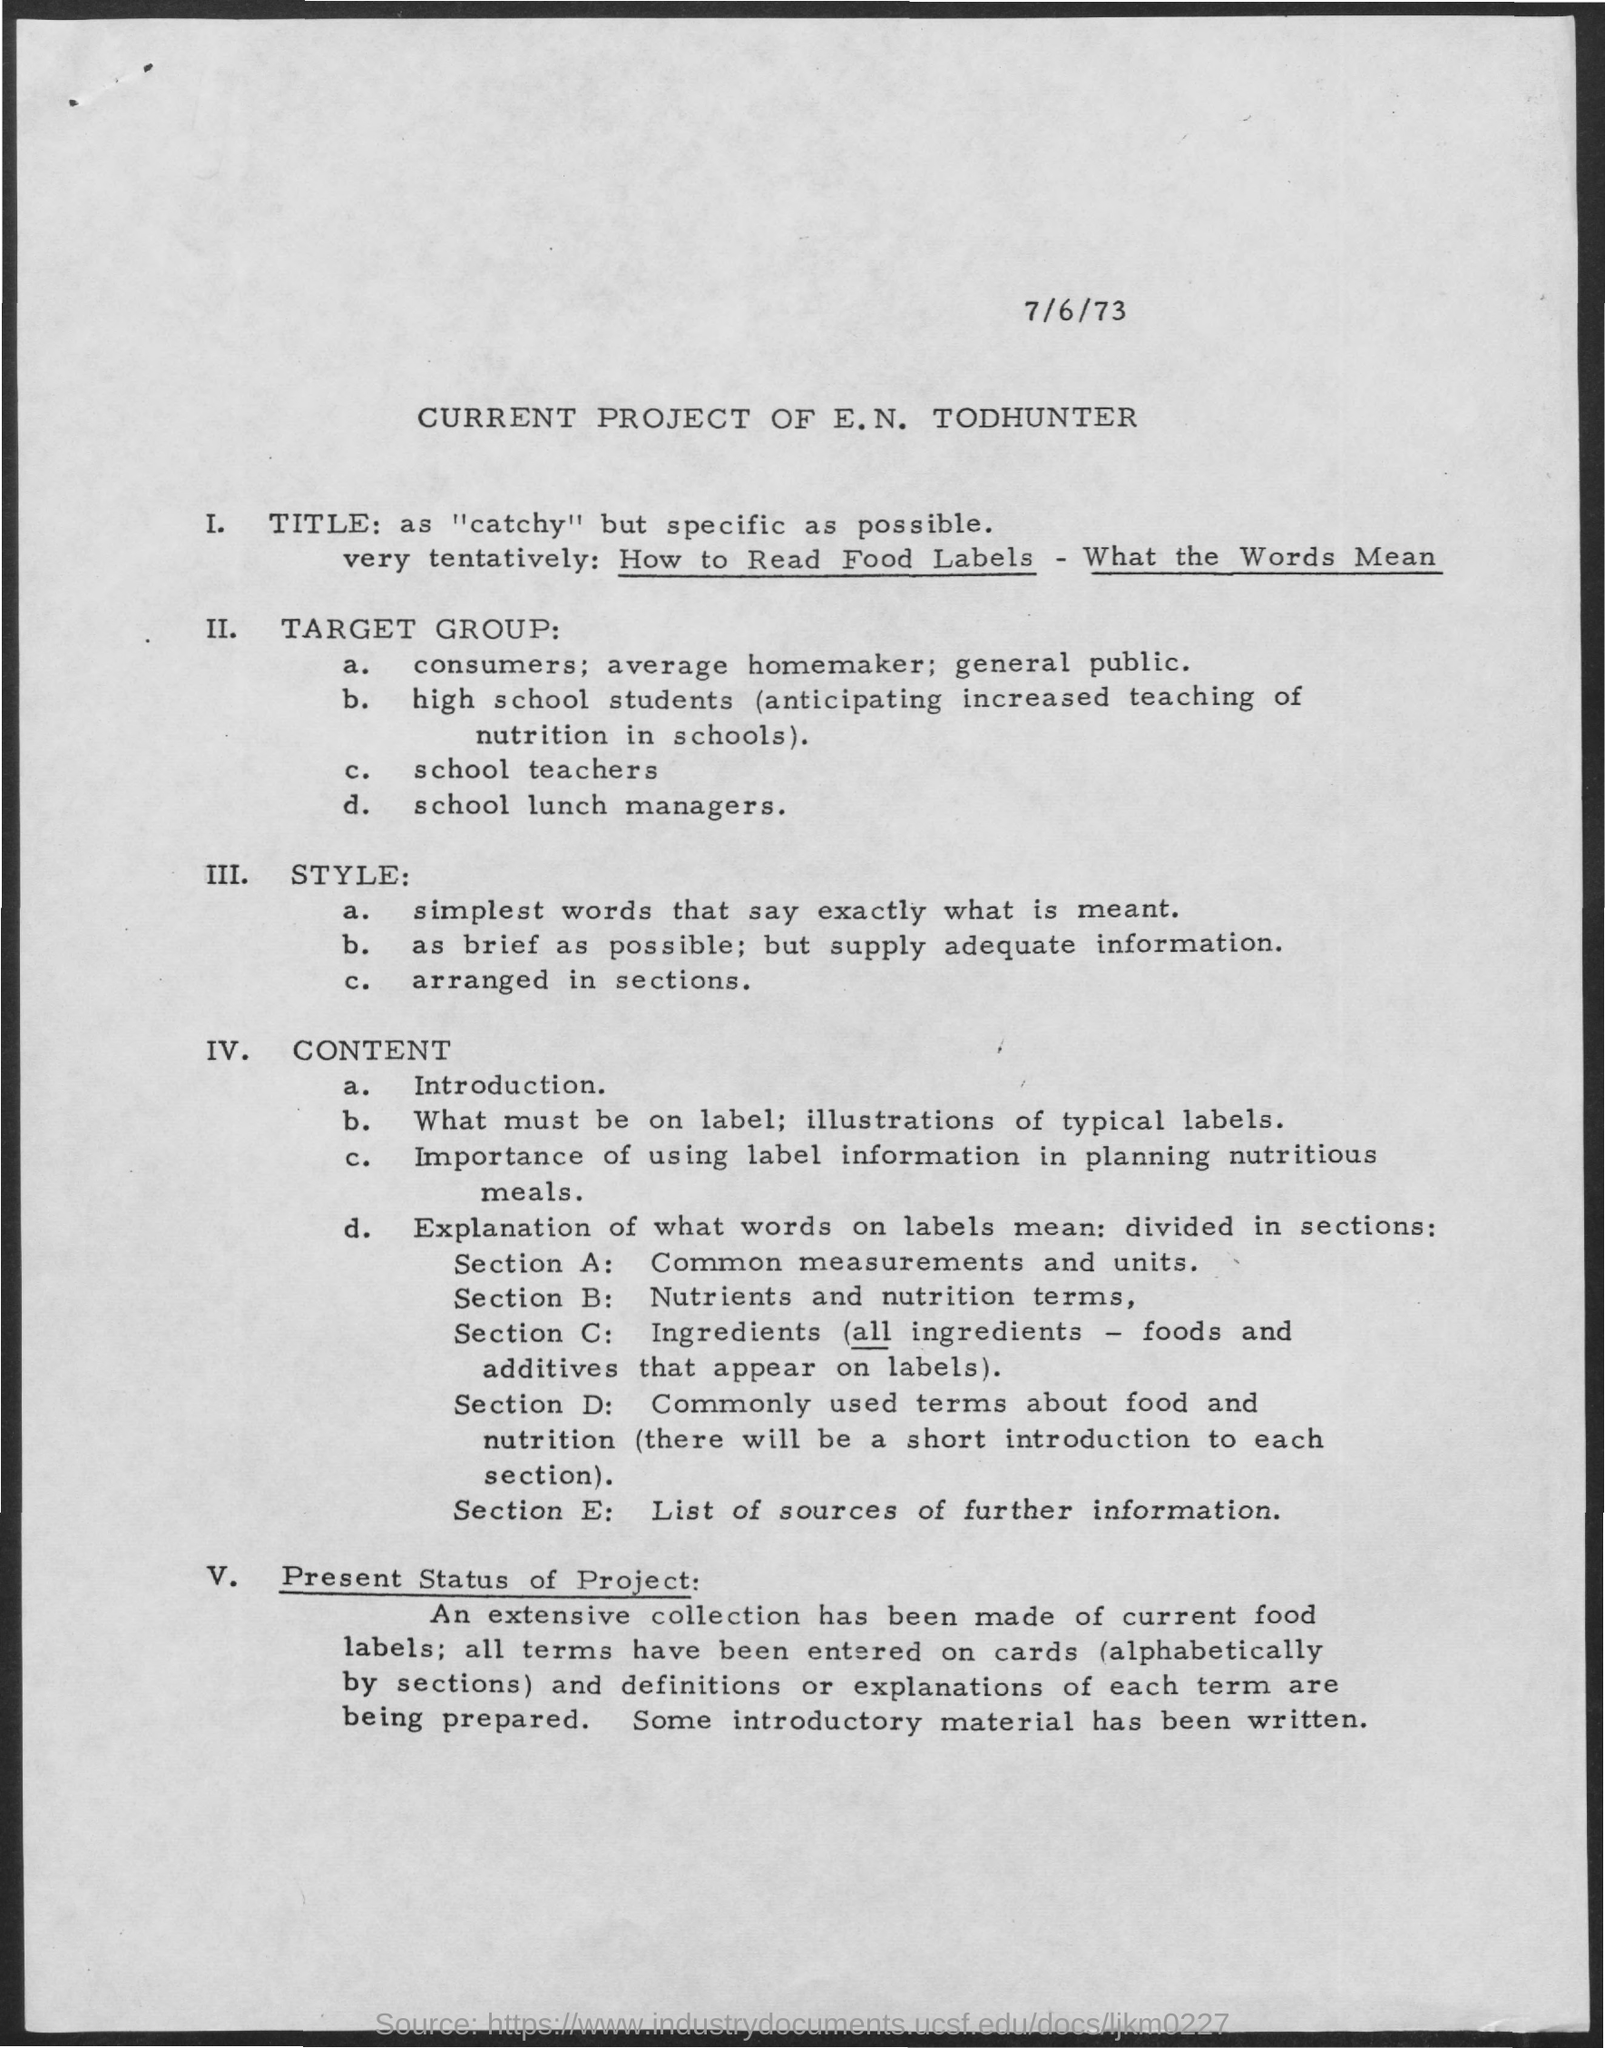Identify some key points in this picture. The commonly used terms about food and nutrition, as mentioned in section D, provide essential knowledge for individuals to make informed decisions about their dietary habits. The common measurements and units mentioned in Section A are described. The title mentioned in the given page is "catchy" and specific as possible. The date mentioned in the given page is July 6, 1973. Section E provides a comprehensive overview of the topic, including information on the history, characteristics, and benefits of the learning style. 